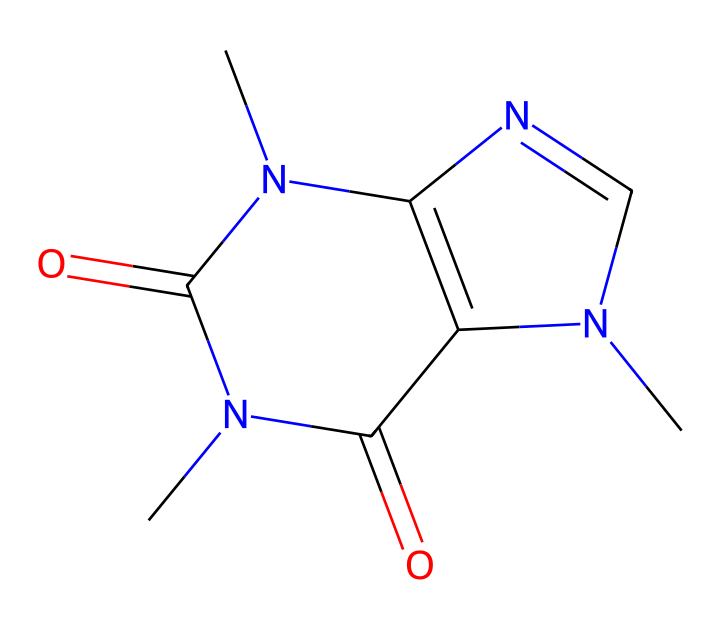What is the molecular formula of caffeine? By analyzing the structure represented by the SMILES notation, we can identify the types and numbers of each atom. The atoms included are carbon (C), hydrogen (H), nitrogen (N), and oxygen (O), leading us to a total of 8 carbon atoms, 10 hydrogen atoms, 4 nitrogen atoms, and 2 oxygen atoms. Therefore, the molecular formula is C8H10N4O2.
Answer: C8H10N4O2 How many nitrogen atoms are in the caffeine structure? Counting the nitrogen atoms in the chemical representation provided, we observe there are 4 nitrogen (N) atoms present in the structure indicated by the SMILES notation.
Answer: 4 What type of functional groups are present in caffeine? Upon examining the structure, we see there are two carbonyl groups (C=O) which are characteristic of ketones and imine groups. Caffeine contains both of these functional groups.
Answer: ketone, imine How many rings are present in the molecular structure of caffeine? By visualizing the structure based on the SMILES, we can see that there are two interconnected ring structures in caffeine's molecular layout. This indicates that caffeine has 2 rings.
Answer: 2 What is the bond type between carbon and nitrogen in caffeine? In caffeine, the bonds between carbon and nitrogen atoms are primarily single bonds, with some additional double bonds involving nitrogen in the structure. The presence of both types reflects the covalent nature of these bonds as seen in the structure.
Answer: single, double What property of caffeine allows it to act as a stimulant? The stimulant properties of caffeine are attributed to its ability to block adenosine receptors in the brain, which are represented in the structure by its nitrogen-containing groups and the overall molecular conformation that enable this interaction.
Answer: nitrogen groups What indicates that caffeine is a ketone? The structural representation displays a carbon atom double bonded to an oxygen atom (C=O), which is the functional group characteristic of ketones. Caffeine thus contains these ketonic features.
Answer: C=O (carbonyl group) 